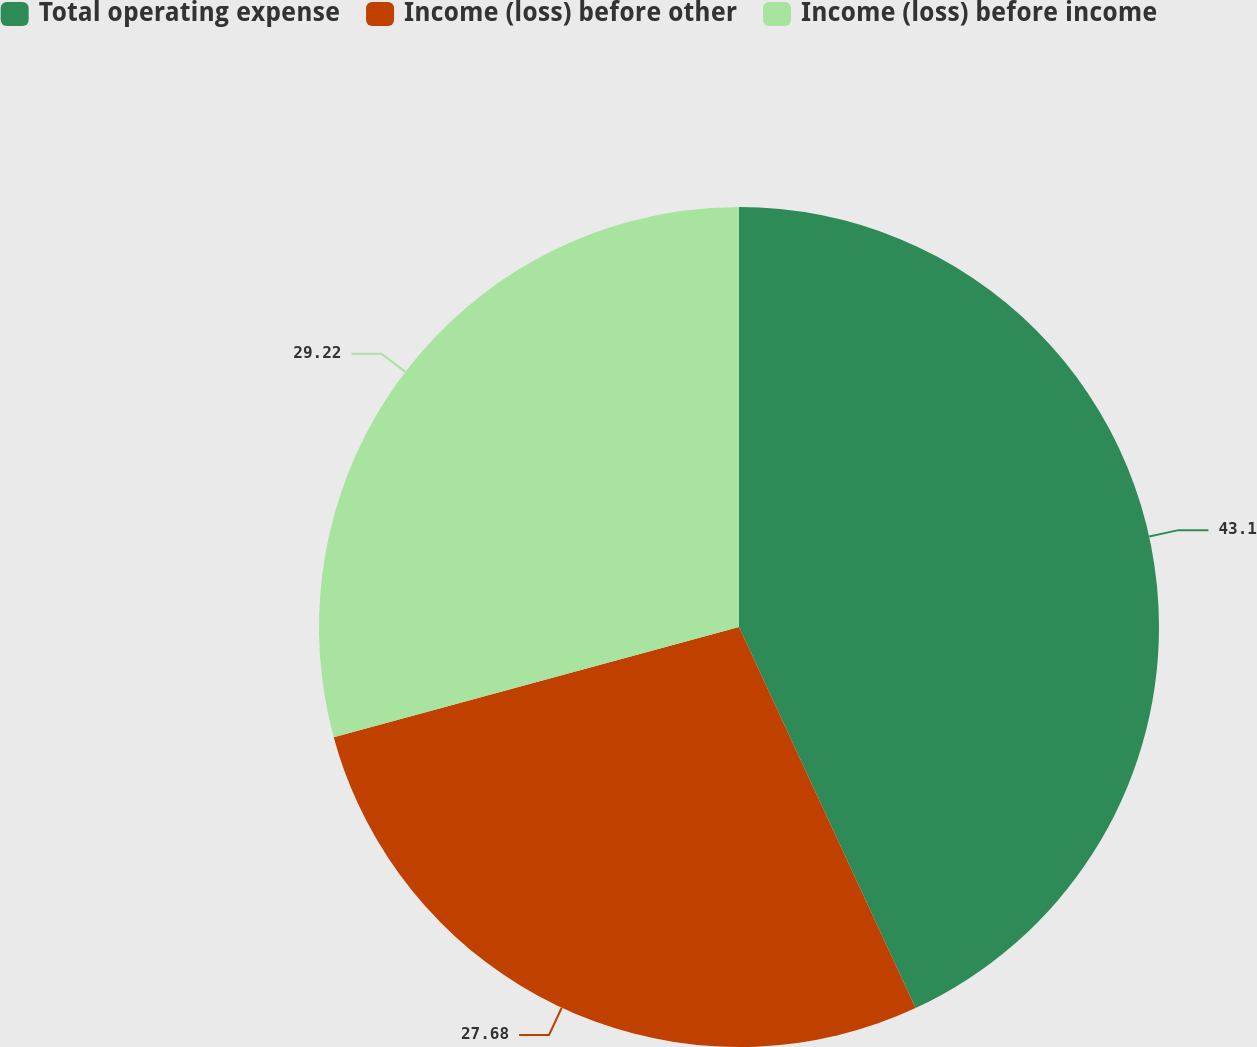Convert chart. <chart><loc_0><loc_0><loc_500><loc_500><pie_chart><fcel>Total operating expense<fcel>Income (loss) before other<fcel>Income (loss) before income<nl><fcel>43.09%<fcel>27.68%<fcel>29.22%<nl></chart> 